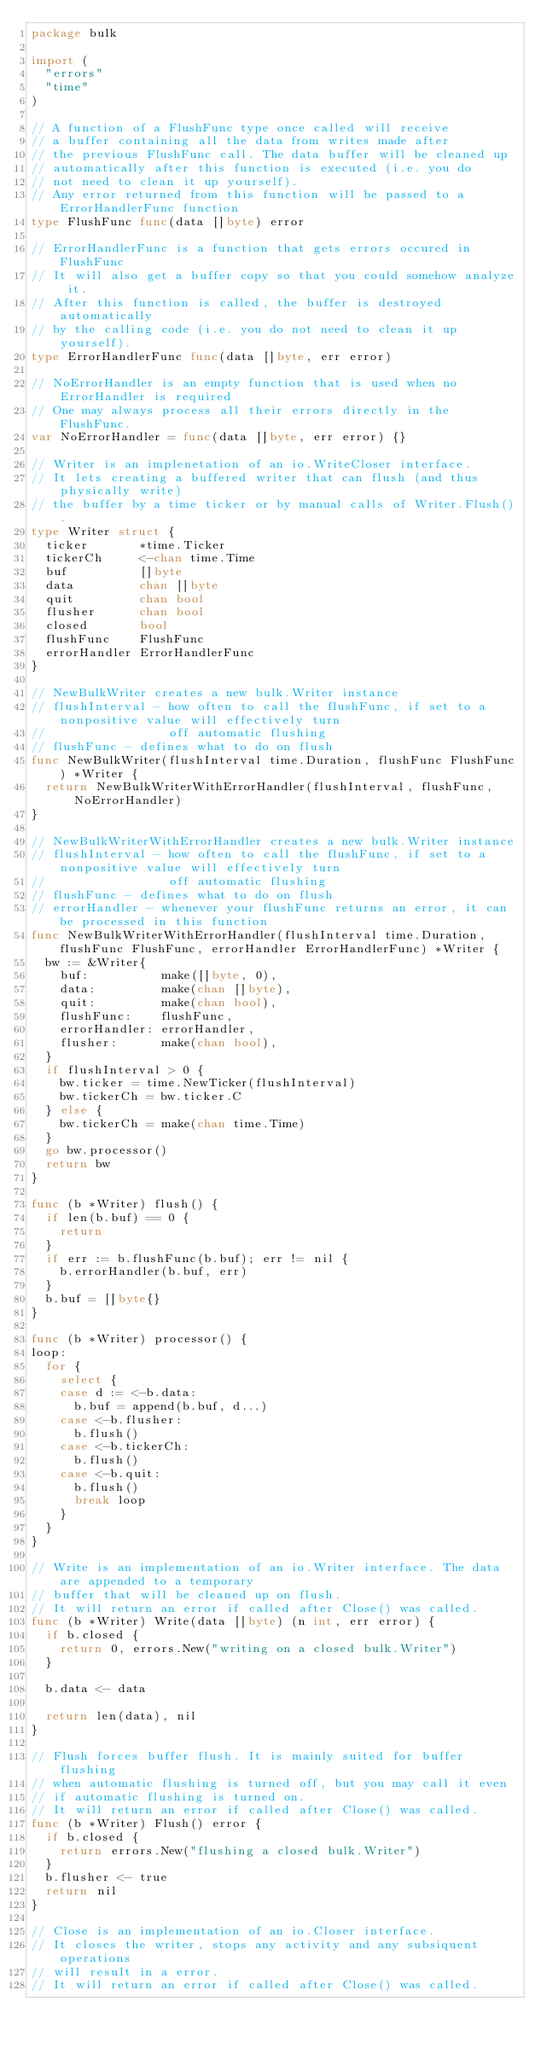Convert code to text. <code><loc_0><loc_0><loc_500><loc_500><_Go_>package bulk

import (
	"errors"
	"time"
)

// A function of a FlushFunc type once called will receive
// a buffer containing all the data from writes made after
// the previous FlushFunc call. The data buffer will be cleaned up
// automatically after this function is executed (i.e. you do
// not need to clean it up yourself).
// Any error returned from this function will be passed to a ErrorHandlerFunc function
type FlushFunc func(data []byte) error

// ErrorHandlerFunc is a function that gets errors occured in FlushFunc
// It will also get a buffer copy so that you could somehow analyze it.
// After this function is called, the buffer is destroyed automatically
// by the calling code (i.e. you do not need to clean it up yourself).
type ErrorHandlerFunc func(data []byte, err error)

// NoErrorHandler is an empty function that is used when no ErrorHandler is required
// One may always process all their errors directly in the FlushFunc.
var NoErrorHandler = func(data []byte, err error) {}

// Writer is an implenetation of an io.WriteCloser interface.
// It lets creating a buffered writer that can flush (and thus physically write)
// the buffer by a time ticker or by manual calls of Writer.Flush().
type Writer struct {
	ticker       *time.Ticker
	tickerCh     <-chan time.Time
	buf          []byte
	data         chan []byte
	quit         chan bool
	flusher      chan bool
	closed       bool
	flushFunc    FlushFunc
	errorHandler ErrorHandlerFunc
}

// NewBulkWriter creates a new bulk.Writer instance
// flushInterval - how often to call the flushFunc, if set to a nonpositive value will effectively turn
//                 off automatic flushing
// flushFunc - defines what to do on flush
func NewBulkWriter(flushInterval time.Duration, flushFunc FlushFunc) *Writer {
	return NewBulkWriterWithErrorHandler(flushInterval, flushFunc, NoErrorHandler)
}

// NewBulkWriterWithErrorHandler creates a new bulk.Writer instance
// flushInterval - how often to call the flushFunc, if set to a nonpositive value will effectively turn
//                 off automatic flushing
// flushFunc - defines what to do on flush
// errorHandler - whenever your flushFunc returns an error, it can be processed in this function
func NewBulkWriterWithErrorHandler(flushInterval time.Duration, flushFunc FlushFunc, errorHandler ErrorHandlerFunc) *Writer {
	bw := &Writer{
		buf:          make([]byte, 0),
		data:         make(chan []byte),
		quit:         make(chan bool),
		flushFunc:    flushFunc,
		errorHandler: errorHandler,
		flusher:      make(chan bool),
	}
	if flushInterval > 0 {
		bw.ticker = time.NewTicker(flushInterval)
		bw.tickerCh = bw.ticker.C
	} else {
		bw.tickerCh = make(chan time.Time)
	}
	go bw.processor()
	return bw
}

func (b *Writer) flush() {
	if len(b.buf) == 0 {
		return
	}
	if err := b.flushFunc(b.buf); err != nil {
		b.errorHandler(b.buf, err)
	}
	b.buf = []byte{}
}

func (b *Writer) processor() {
loop:
	for {
		select {
		case d := <-b.data:
			b.buf = append(b.buf, d...)
		case <-b.flusher:
			b.flush()
		case <-b.tickerCh:
			b.flush()
		case <-b.quit:
			b.flush()
			break loop
		}
	}
}

// Write is an implementation of an io.Writer interface. The data are appended to a temporary
// buffer that will be cleaned up on flush.
// It will return an error if called after Close() was called.
func (b *Writer) Write(data []byte) (n int, err error) {
	if b.closed {
		return 0, errors.New("writing on a closed bulk.Writer")
	}

	b.data <- data

	return len(data), nil
}

// Flush forces buffer flush. It is mainly suited for buffer flushing
// when automatic flushing is turned off, but you may call it even
// if automatic flushing is turned on.
// It will return an error if called after Close() was called.
func (b *Writer) Flush() error {
	if b.closed {
		return errors.New("flushing a closed bulk.Writer")
	}
	b.flusher <- true
	return nil
}

// Close is an implementation of an io.Closer interface.
// It closes the writer, stops any activity and any subsiquent operations
// will result in a error.
// It will return an error if called after Close() was called.</code> 